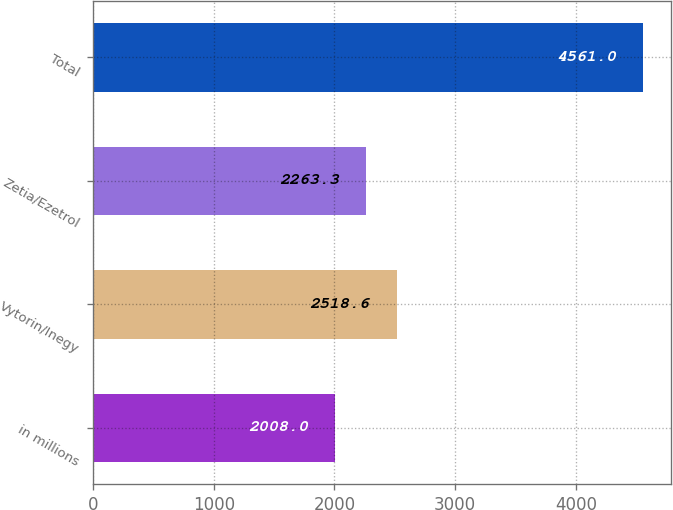Convert chart to OTSL. <chart><loc_0><loc_0><loc_500><loc_500><bar_chart><fcel>in millions<fcel>Vytorin/Inegy<fcel>Zetia/Ezetrol<fcel>Total<nl><fcel>2008<fcel>2518.6<fcel>2263.3<fcel>4561<nl></chart> 